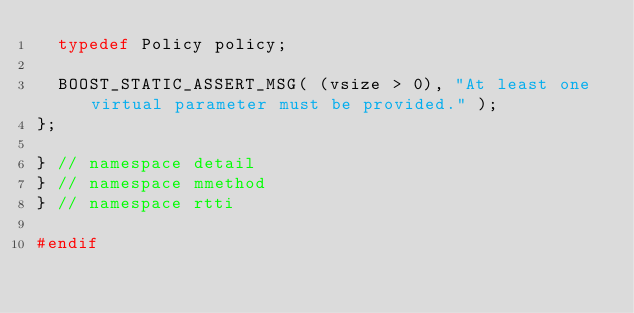<code> <loc_0><loc_0><loc_500><loc_500><_C++_>  typedef Policy policy;

  BOOST_STATIC_ASSERT_MSG( (vsize > 0), "At least one virtual parameter must be provided." );
};

} // namespace detail
} // namespace mmethod
} // namespace rtti

#endif
</code> 